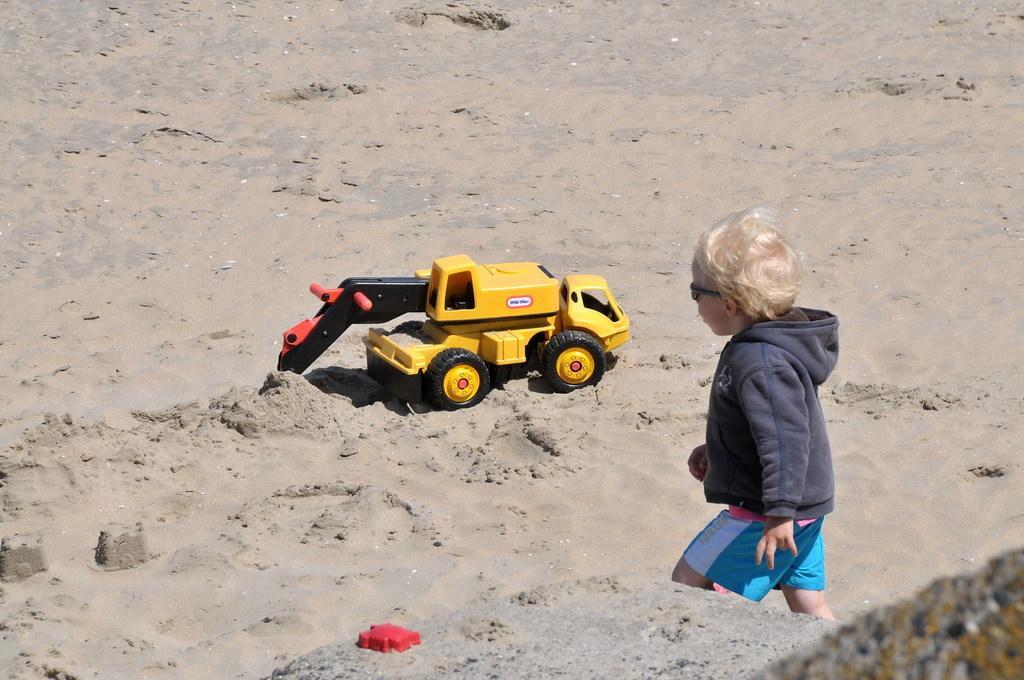Could you give a brief overview of what you see in this image? In this image we can see one boy with black sunglasses walking on the sand, right side corner of the image one object on the ground, some sand, one red color toy and one yellow toy on the ground. 